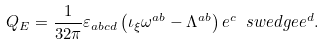<formula> <loc_0><loc_0><loc_500><loc_500>Q _ { E } = \frac { 1 } { 3 2 \pi } \varepsilon _ { a b c d } \left ( \iota _ { \xi } \omega ^ { a b } - \Lambda ^ { a b } \right ) e ^ { c } \ s w e d g e e ^ { d } .</formula> 